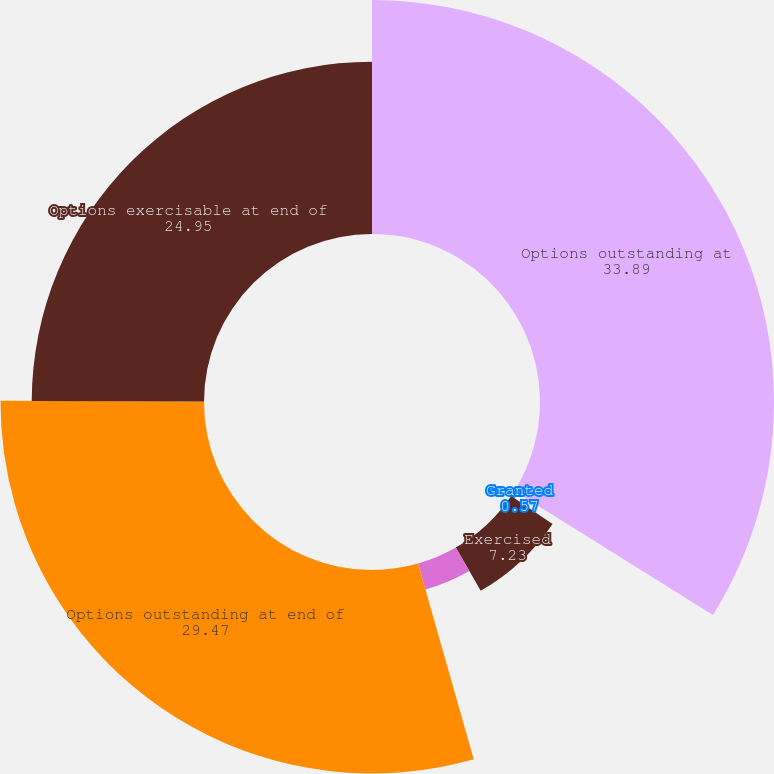<chart> <loc_0><loc_0><loc_500><loc_500><pie_chart><fcel>Options outstanding at<fcel>Granted<fcel>Exercised<fcel>Canceled(2)<fcel>Options outstanding at end of<fcel>Options exercisable at end of<nl><fcel>33.89%<fcel>0.57%<fcel>7.23%<fcel>3.9%<fcel>29.47%<fcel>24.95%<nl></chart> 